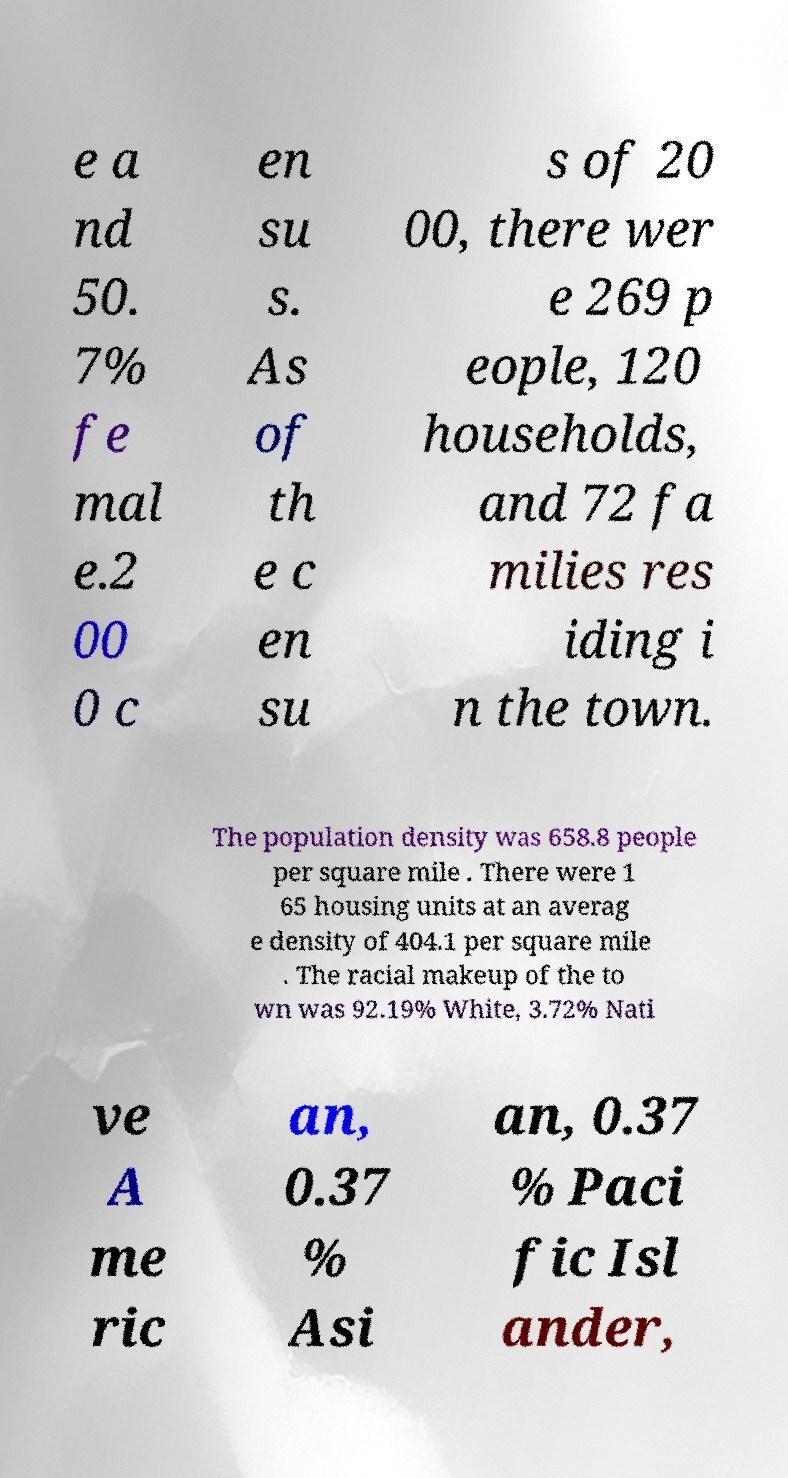Please identify and transcribe the text found in this image. e a nd 50. 7% fe mal e.2 00 0 c en su s. As of th e c en su s of 20 00, there wer e 269 p eople, 120 households, and 72 fa milies res iding i n the town. The population density was 658.8 people per square mile . There were 1 65 housing units at an averag e density of 404.1 per square mile . The racial makeup of the to wn was 92.19% White, 3.72% Nati ve A me ric an, 0.37 % Asi an, 0.37 % Paci fic Isl ander, 